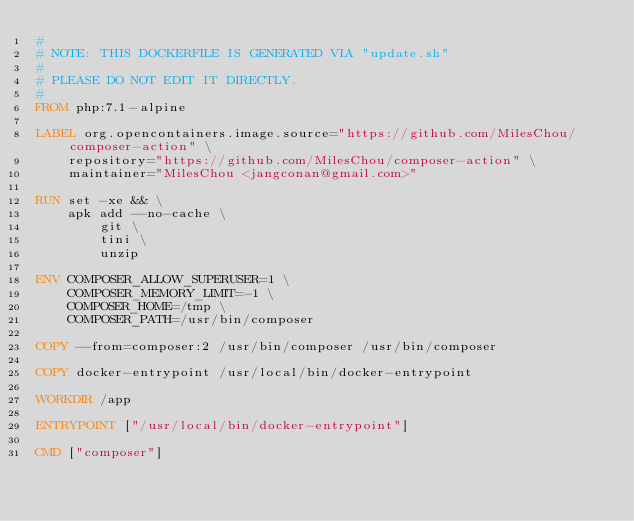<code> <loc_0><loc_0><loc_500><loc_500><_Dockerfile_>#
# NOTE: THIS DOCKERFILE IS GENERATED VIA "update.sh"
#
# PLEASE DO NOT EDIT IT DIRECTLY.
#
FROM php:7.1-alpine

LABEL org.opencontainers.image.source="https://github.com/MilesChou/composer-action" \
    repository="https://github.com/MilesChou/composer-action" \
    maintainer="MilesChou <jangconan@gmail.com>"

RUN set -xe && \
    apk add --no-cache \
        git \
        tini \
        unzip

ENV COMPOSER_ALLOW_SUPERUSER=1 \
    COMPOSER_MEMORY_LIMIT=-1 \
    COMPOSER_HOME=/tmp \
    COMPOSER_PATH=/usr/bin/composer

COPY --from=composer:2 /usr/bin/composer /usr/bin/composer

COPY docker-entrypoint /usr/local/bin/docker-entrypoint

WORKDIR /app

ENTRYPOINT ["/usr/local/bin/docker-entrypoint"]

CMD ["composer"]
</code> 